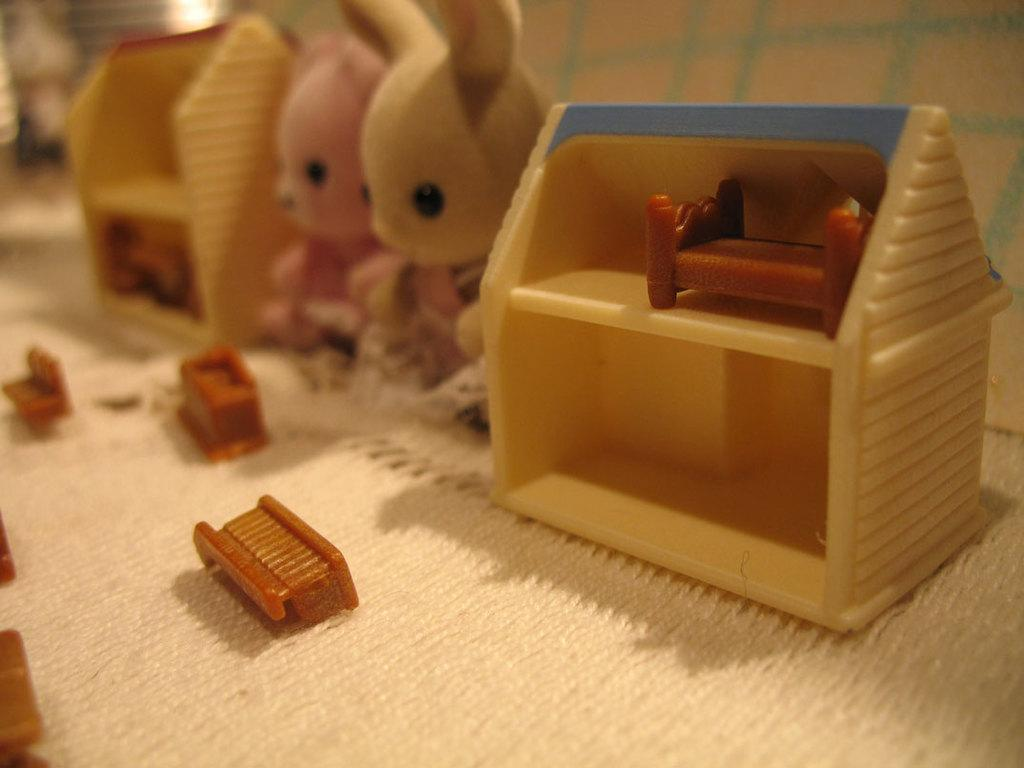What objects are present in the image? There are toys in the image. How are the toys arranged or placed? The toys are on a cloth. Can you describe the background of the image? The background of the image is blurry. Are there any cobwebs visible on the toys in the image? There is no mention of cobwebs in the provided facts, and therefore we cannot determine if any are present in the image. 